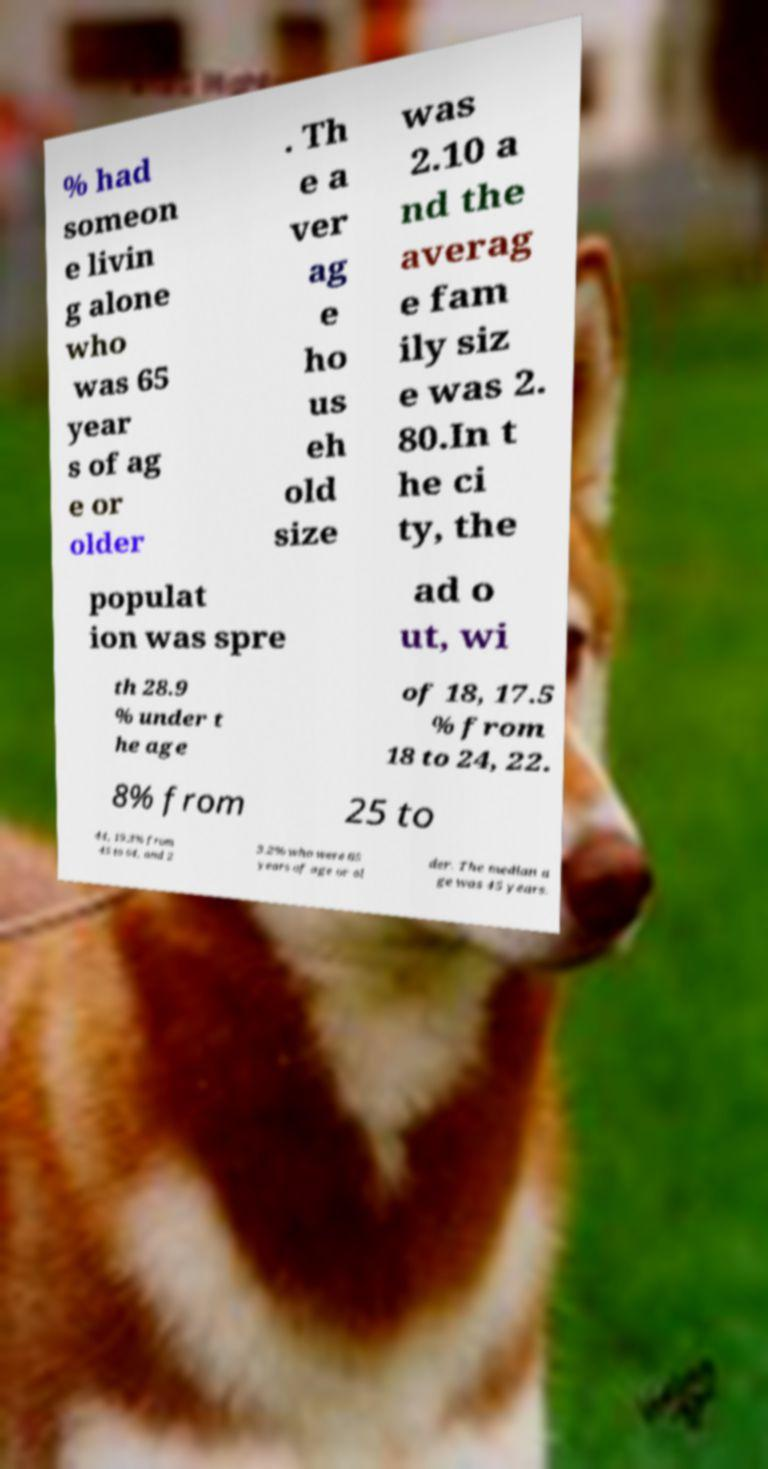There's text embedded in this image that I need extracted. Can you transcribe it verbatim? % had someon e livin g alone who was 65 year s of ag e or older . Th e a ver ag e ho us eh old size was 2.10 a nd the averag e fam ily siz e was 2. 80.In t he ci ty, the populat ion was spre ad o ut, wi th 28.9 % under t he age of 18, 17.5 % from 18 to 24, 22. 8% from 25 to 44, 19.3% from 45 to 64, and 2 3.2% who were 65 years of age or ol der. The median a ge was 45 years. 